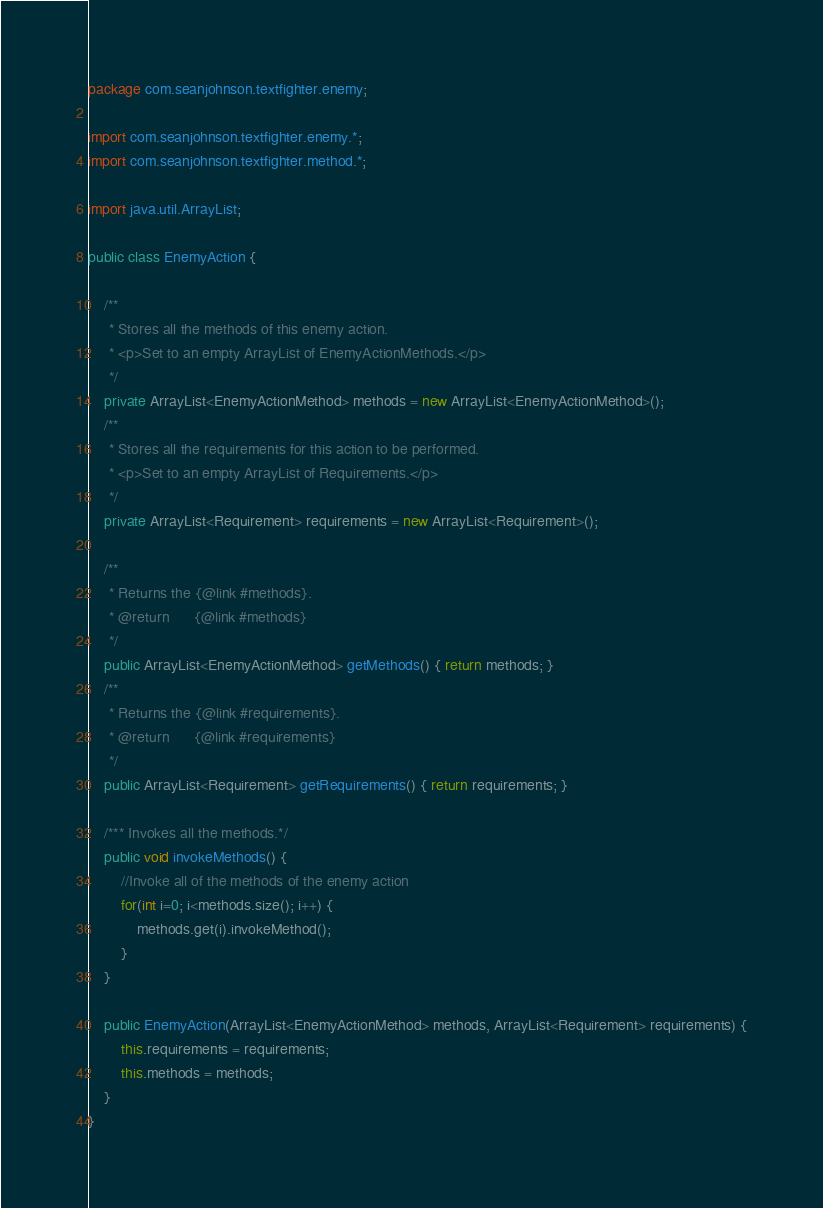<code> <loc_0><loc_0><loc_500><loc_500><_Java_>package com.seanjohnson.textfighter.enemy;

import com.seanjohnson.textfighter.enemy.*;
import com.seanjohnson.textfighter.method.*;

import java.util.ArrayList;

public class EnemyAction {

    /**
     * Stores all the methods of this enemy action.
     * <p>Set to an empty ArrayList of EnemyActionMethods.</p>
     */
    private ArrayList<EnemyActionMethod> methods = new ArrayList<EnemyActionMethod>();
    /**
     * Stores all the requirements for this action to be performed.
     * <p>Set to an empty ArrayList of Requirements.</p>
     */
    private ArrayList<Requirement> requirements = new ArrayList<Requirement>();

    /**
     * Returns the {@link #methods}.
     * @return      {@link #methods}
     */
    public ArrayList<EnemyActionMethod> getMethods() { return methods; }
    /**
     * Returns the {@link #requirements}.
     * @return      {@link #requirements}
     */
    public ArrayList<Requirement> getRequirements() { return requirements; }

    /*** Invokes all the methods.*/
    public void invokeMethods() {
        //Invoke all of the methods of the enemy action
        for(int i=0; i<methods.size(); i++) {
            methods.get(i).invokeMethod();
        }
    }

    public EnemyAction(ArrayList<EnemyActionMethod> methods, ArrayList<Requirement> requirements) {
        this.requirements = requirements;
        this.methods = methods;
    }
}
</code> 